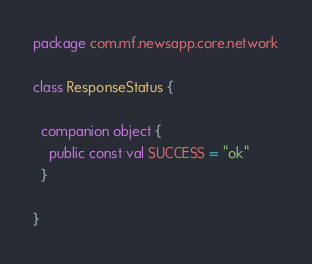<code> <loc_0><loc_0><loc_500><loc_500><_Kotlin_>package com.mf.newsapp.core.network

class ResponseStatus {

  companion object {
    public const val SUCCESS = "ok"
  }

}</code> 